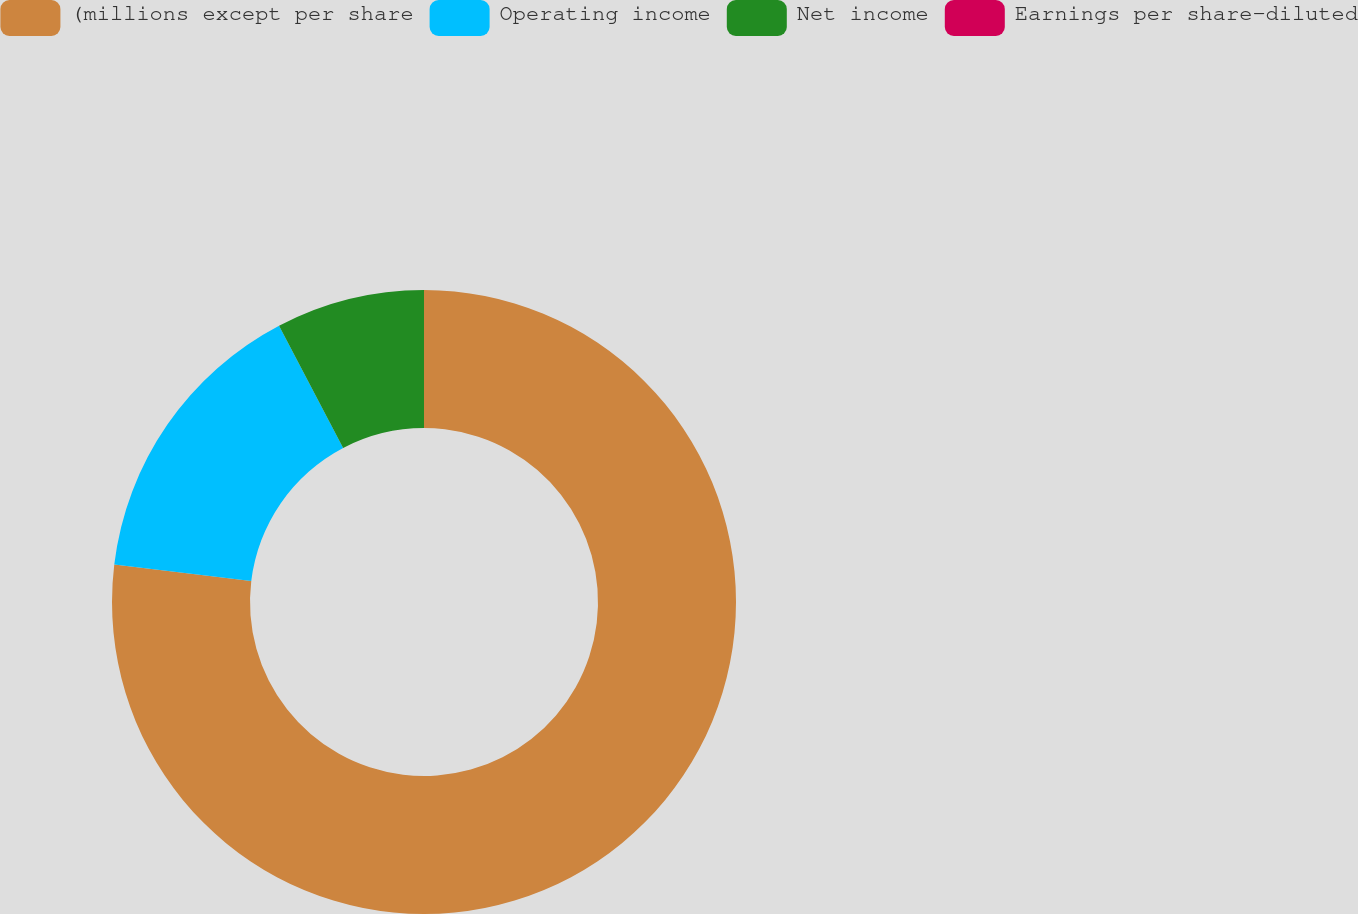Convert chart to OTSL. <chart><loc_0><loc_0><loc_500><loc_500><pie_chart><fcel>(millions except per share<fcel>Operating income<fcel>Net income<fcel>Earnings per share-diluted<nl><fcel>76.92%<fcel>15.39%<fcel>7.69%<fcel>0.0%<nl></chart> 